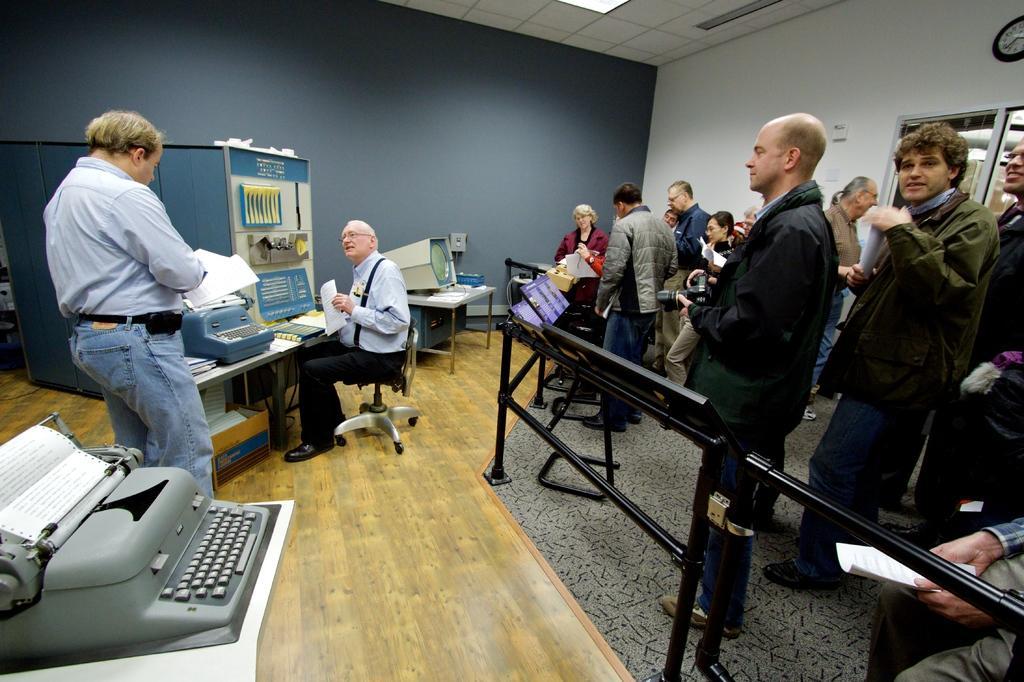Could you give a brief overview of what you see in this image? In this image a person is sitting on the chair. He is holding a paper in his hand. Before him there is a table having a typewriter machine and there is a on it. Beside there is a person standing on the floor and he is holding a book in his hand. Left side there is a type writer machine having a paper on it. It is on the table. Behind the fence few persons are standing on the floor. A person wearing a black jacket is holding a camera in his hand. Beside there is a person holding a paper in his hand. A clock is attached to the wall. Below it there is a door. 